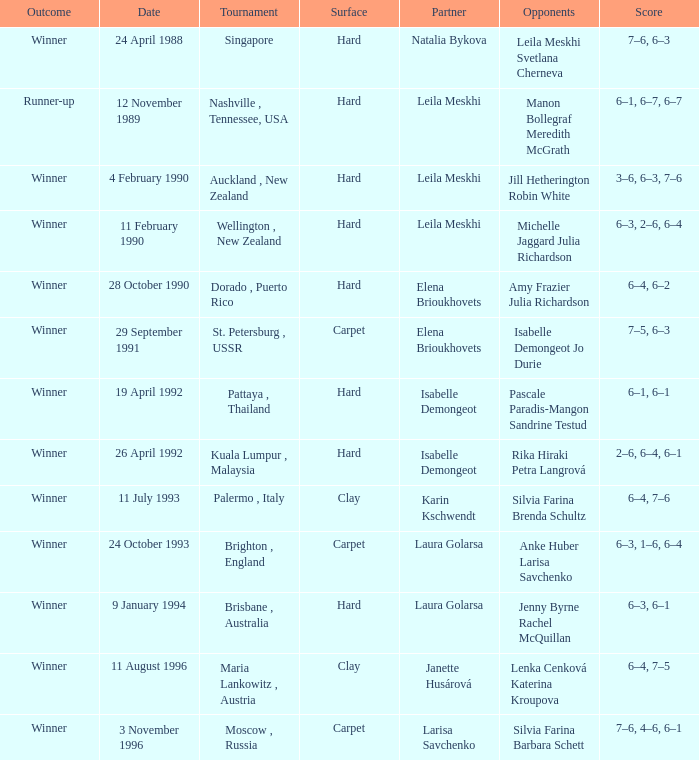On what day was the score 6-4, 6-2? 28 October 1990. 